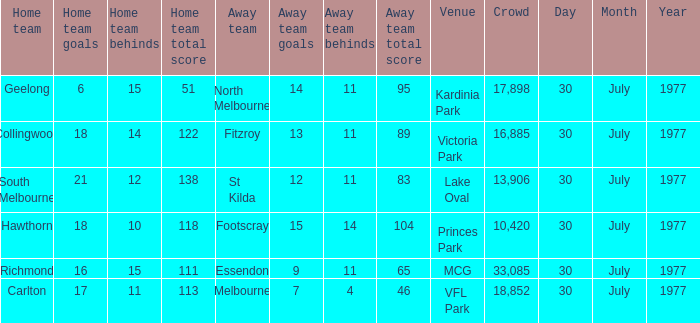Parse the table in full. {'header': ['Home team', 'Home team goals', 'Home team behinds', 'Home team total score', 'Away team', 'Away team goals', 'Away team behinds', 'Away team total score', 'Venue', 'Crowd', 'Day', 'Month', 'Year'], 'rows': [['Geelong', '6', '15', '51', 'North Melbourne', '14', '11', '95', 'Kardinia Park', '17,898', '30', 'July', '1977'], ['Collingwood', '18', '14', '122', 'Fitzroy', '13', '11', '89', 'Victoria Park', '16,885', '30', 'July', '1977'], ['South Melbourne', '21', '12', '138', 'St Kilda', '12', '11', '83', 'Lake Oval', '13,906', '30', 'July', '1977'], ['Hawthorn', '18', '10', '118', 'Footscray', '15', '14', '104', 'Princes Park', '10,420', '30', 'July', '1977'], ['Richmond', '16', '15', '111', 'Essendon', '9', '11', '65', 'MCG', '33,085', '30', 'July', '1977'], ['Carlton', '17', '11', '113', 'Melbourne', '7', '4', '46', 'VFL Park', '18,852', '30', 'July', '1977']]} Whom is the home team when the away team score is 9.11 (65)? Richmond. 